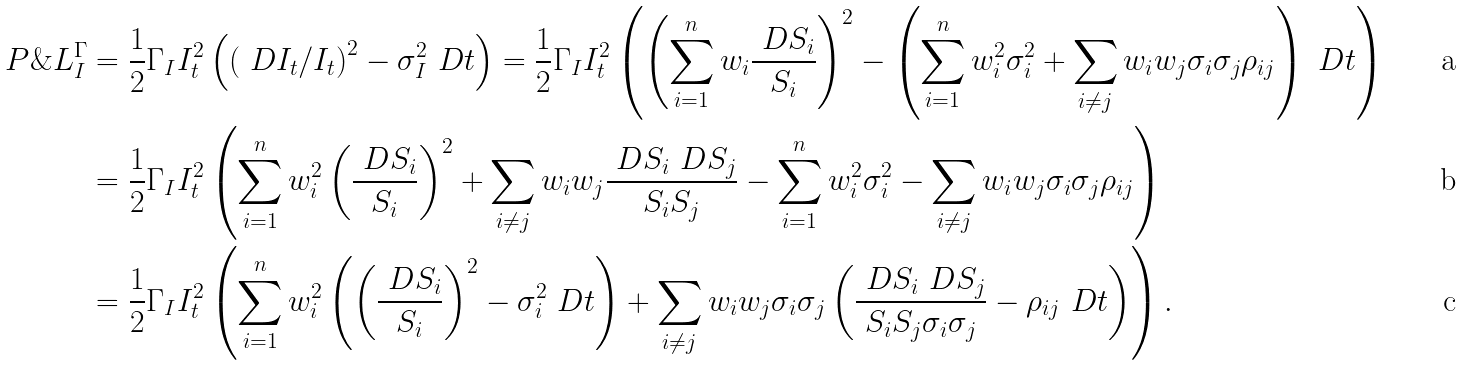<formula> <loc_0><loc_0><loc_500><loc_500>P \& L _ { I } ^ { \Gamma } & = \frac { 1 } { 2 } \Gamma _ { I } I _ { t } ^ { 2 } \left ( \left ( \ D I _ { t } / I _ { t } \right ) ^ { 2 } - \sigma _ { I } ^ { 2 } \ D t \right ) = \frac { 1 } { 2 } \Gamma _ { I } I _ { t } ^ { 2 } \left ( \left ( \sum _ { i = 1 } ^ { n } w _ { i } \frac { \ D S _ { i } } { S _ { i } } \right ) ^ { 2 } - \left ( \sum _ { i = 1 } ^ { n } w _ { i } ^ { 2 } \sigma _ { i } ^ { 2 } + \sum _ { i \ne j } w _ { i } w _ { j } \sigma _ { i } \sigma _ { j } \rho _ { i j } \right ) \ D t \right ) \\ & = \frac { 1 } { 2 } \Gamma _ { I } I _ { t } ^ { 2 } \left ( \sum _ { i = 1 } ^ { n } w _ { i } ^ { 2 } \left ( \frac { \ D S _ { i } } { S _ { i } } \right ) ^ { 2 } + \sum _ { i \ne j } w _ { i } w _ { j } \frac { \ D S _ { i } \ D S _ { j } } { S _ { i } S _ { j } } - \sum _ { i = 1 } ^ { n } w _ { i } ^ { 2 } \sigma _ { i } ^ { 2 } - \sum _ { i \ne j } w _ { i } w _ { j } \sigma _ { i } \sigma _ { j } \rho _ { i j } \right ) \\ & = \frac { 1 } { 2 } \Gamma _ { I } I _ { t } ^ { 2 } \left ( \sum _ { i = 1 } ^ { n } w _ { i } ^ { 2 } \left ( \left ( \frac { \ D S _ { i } } { S _ { i } } \right ) ^ { 2 } - \sigma _ { i } ^ { 2 } \ D t \right ) + \sum _ { i \ne j } w _ { i } w _ { j } \sigma _ { i } \sigma _ { j } \left ( \frac { \ D S _ { i } \ D S _ { j } } { S _ { i } S _ { j } \sigma _ { i } \sigma _ { j } } - \rho _ { i j } \ D t \right ) \right ) .</formula> 